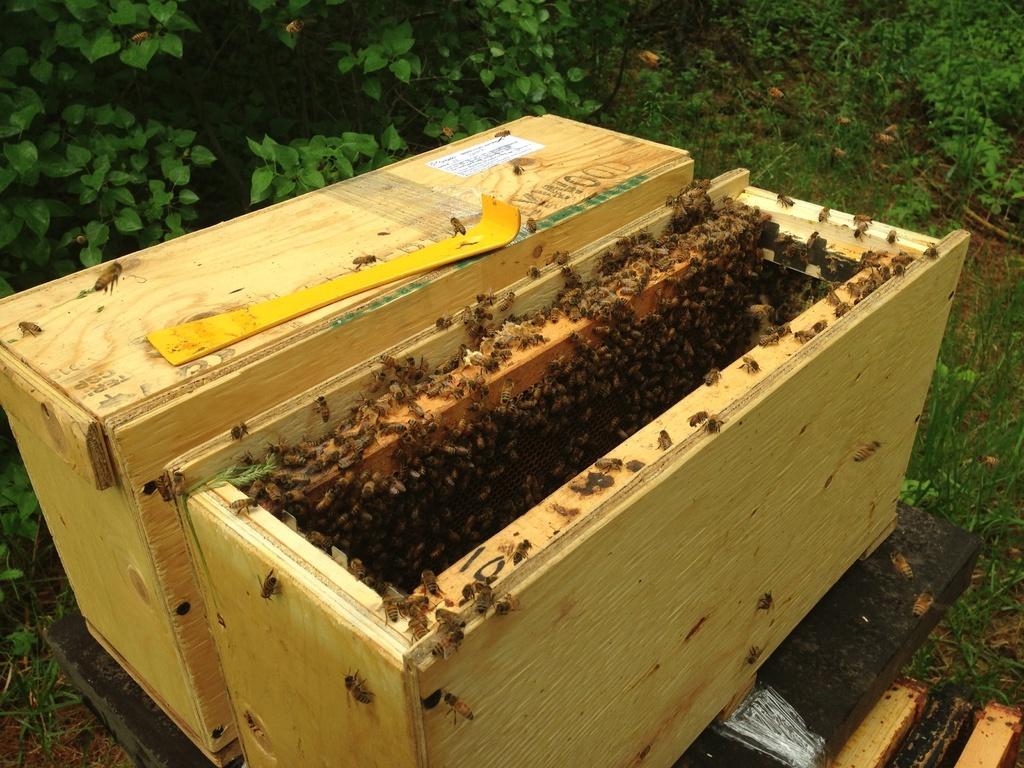How would you summarize this image in a sentence or two? In this picture we can see honey bees in a wooden box. On the left side of the picture we can see wooden box. On the wooden box we can see a yellow object. In the bottom right corner of the picture we can see wooden objects. We can see leaves, plants and grass. 